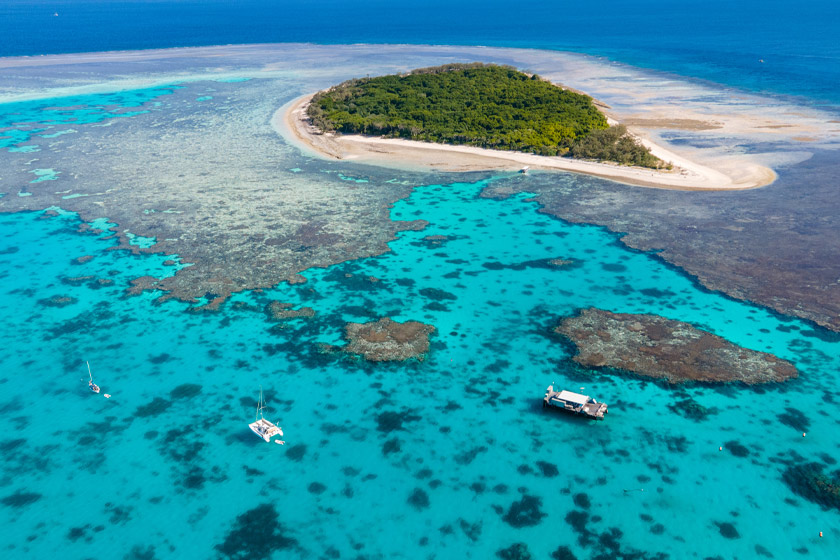What kind of wildlife might we find in this image? The vibrant ecosystem of the Great Barrier Reef is home to a rich variety of marine life. In this image, underwater, you might find colorful fish darting around the coral formations, such as clownfish, parrotfish, and angelfish. There could also be sea turtles gracefully gliding through the water, as well as rays and small reef sharks exploring the coral beds. Among the coral, you might spot mollusks, starfish, and anemones contributing to the reef's bustling underwater community. What types of coral can one expect? The Great Barrier Reef is renowned for its diverse coral species. In the image, you'd likely find hard corals such as brain coral, staghorn coral, and elkhorn coral, characterized by their complex, sturdy structures which provide vital habitats for other marine life. Soft corals, like sea fans and leather corals, add to the reef's diversity with their flexible, often vibrant forms swaying in the water currents. These various coral species not only contribute to the reef’s structural complexity but also its dazzling array of colors and patterns. Imagine there's a hidden treasure buried on this island, how might that story go? Legends speak of a pirate captain named Blackfin, who once roamed the vast oceans with his loyal crew. After years of plundering, Blackfin decided to hide his most prized treasures on a secluded island in the heart of the Great Barrier Reef. The island, lush with dense forest and surrounded by vibrant coral reefs, provided the perfect cover. Blackfin and his crew buried the treasure deep in the sands, marking the spot with a unique coral formation that blended seamlessly with the natural landscape. Over time, the story of Blackfin's hidden fortune became a myth passed down among sailors and adventurers. Today, as the boats in the image float near the island, they might carry hopeful treasure hunters, scanning the coral reefs and dense undergrowth for any clue that could lead to the legendary pirate's riches. 